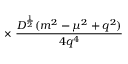Convert formula to latex. <formula><loc_0><loc_0><loc_500><loc_500>\times \, \frac { D ^ { \frac { 1 } { 2 } } ( m ^ { 2 } - \mu ^ { 2 } + q ^ { 2 } ) } { 4 q ^ { 4 } }</formula> 